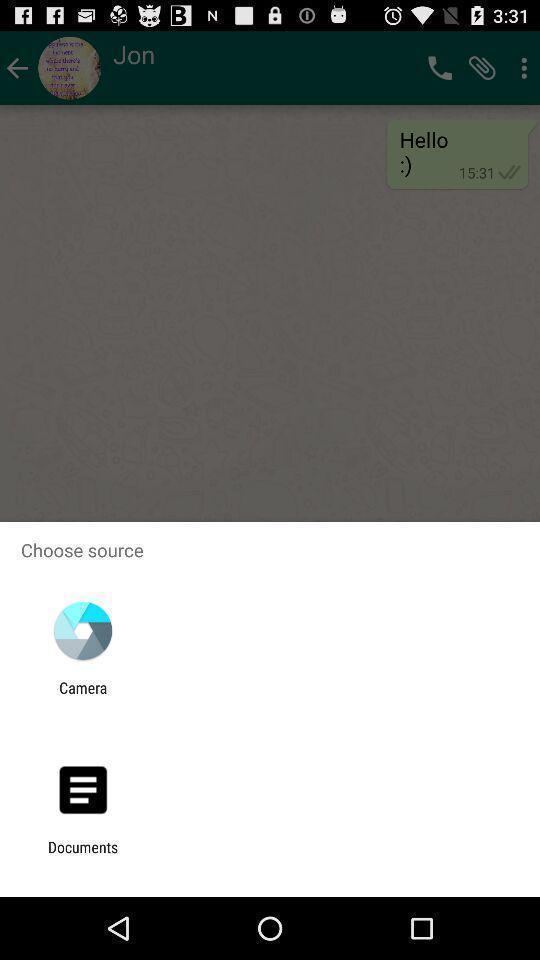Give me a narrative description of this picture. Pop-up showing to choose a source to select a picture. 